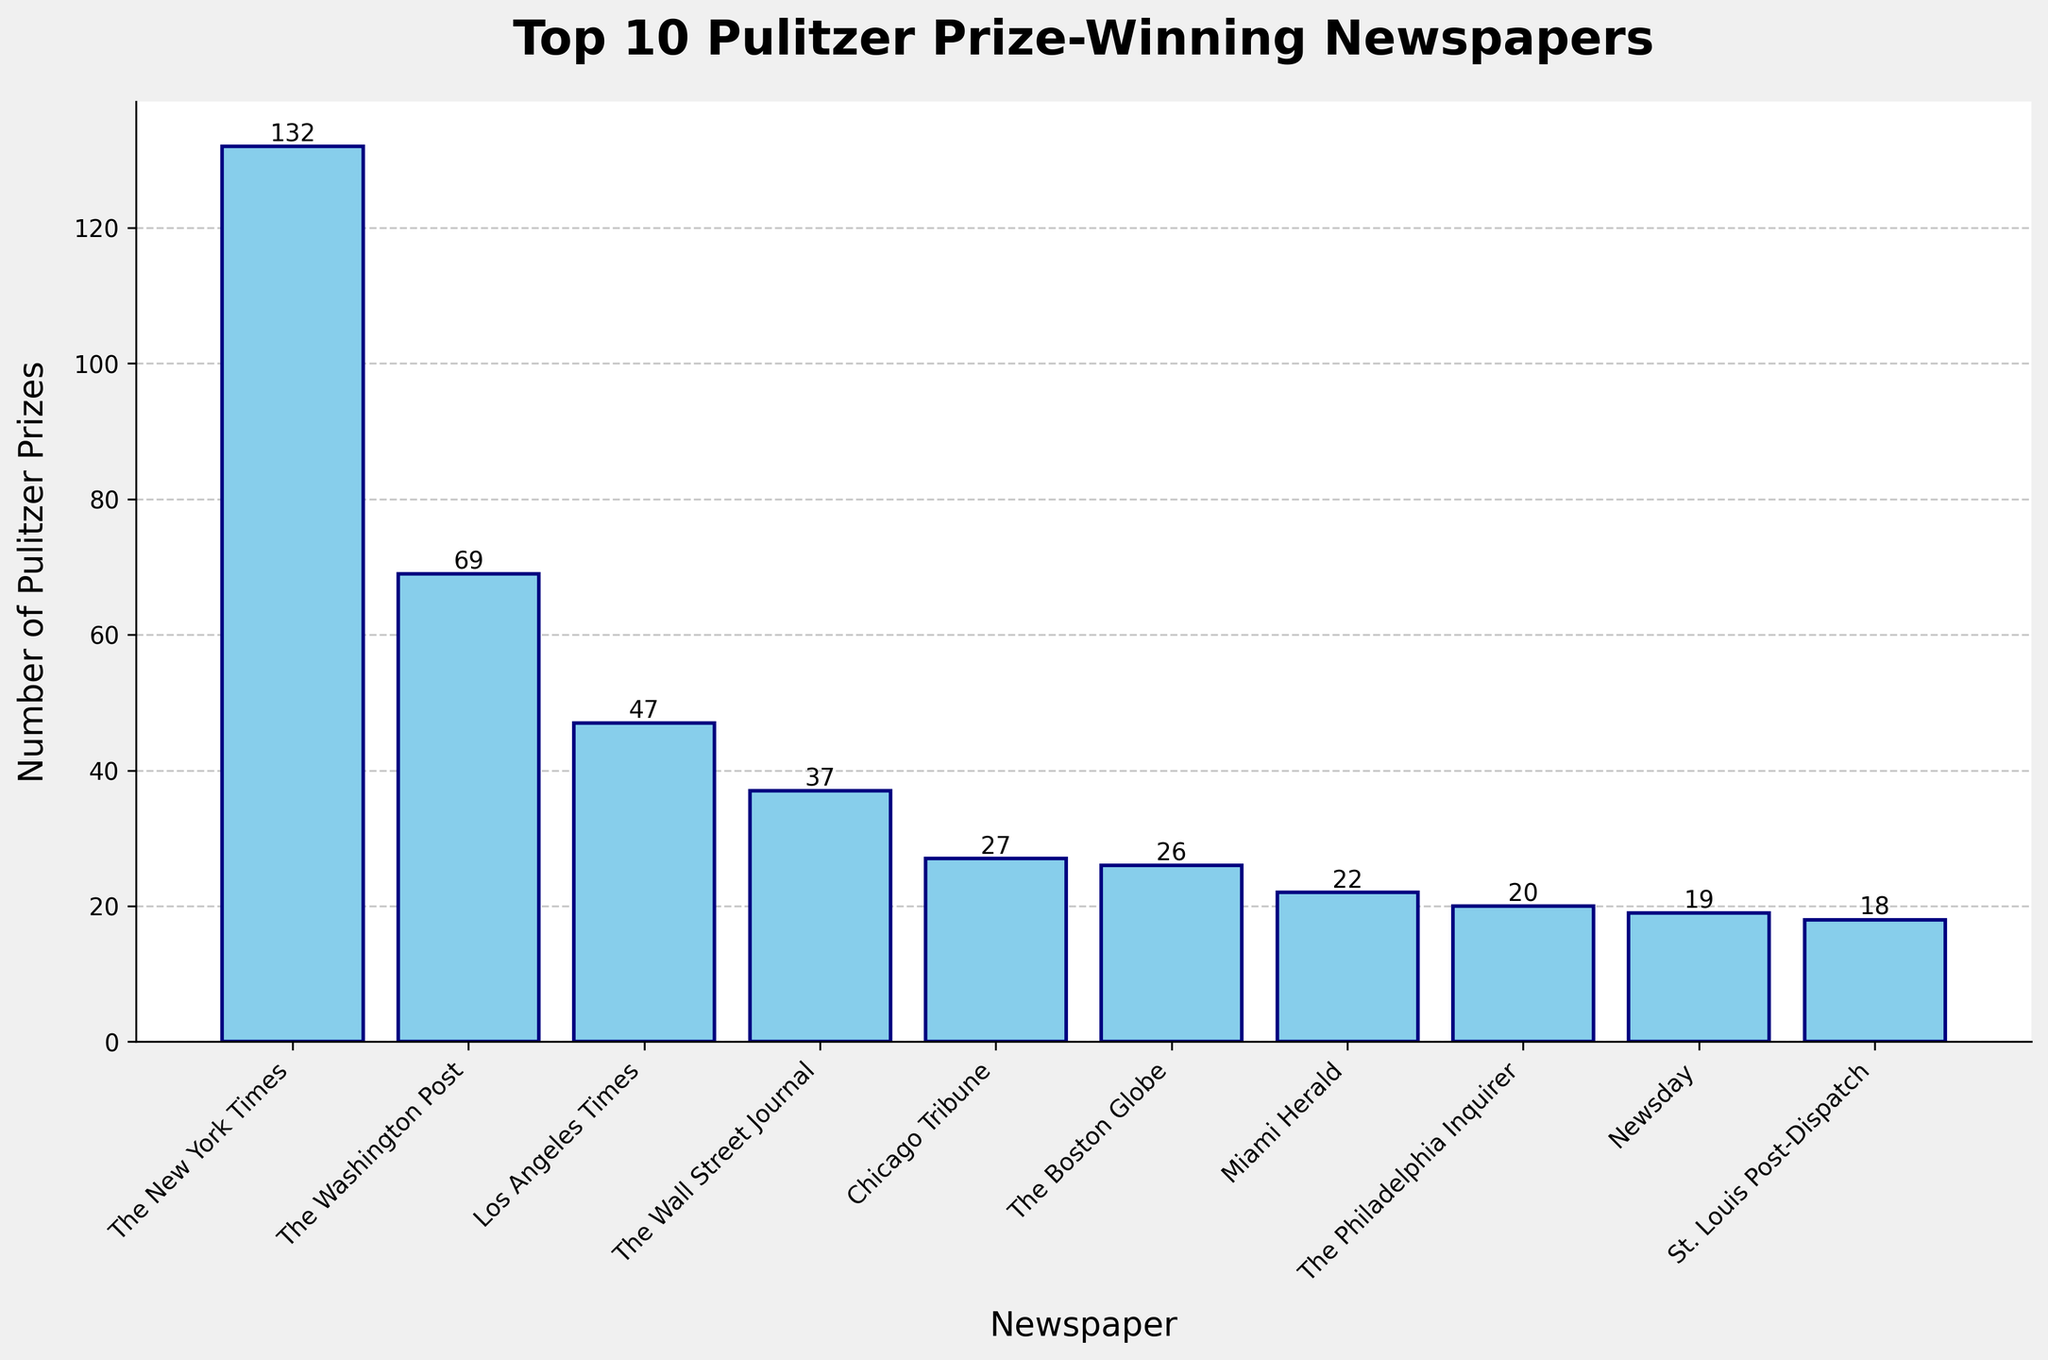Which newspaper has won the most Pulitzer Prizes? The tallest bar represents the newspaper with the most Pulitzer Prizes. The New York Times, with a bar height of 132.
Answer: The New York Times How many Pulitzer Prizes has the Los Angeles Times won? Locate the bar for the Los Angeles Times and look at the value labeled on top of the bar, which is 47.
Answer: 47 What is the difference in Pulitzer Prizes between The New York Times and The Washington Post? The New York Times has 132 prizes and The Washington Post has 69. Subtract 69 from 132 to find the difference. 132 - 69 = 63
Answer: 63 Which newspapers have won between 10 and 25 Pulitzer Prizes? Look at the bars representing values between 10 and 25. The Philadelphia Inquirer (20), Miami Herald (22), Newsday (19), St. Louis Post-Dispatch (18), The Seattle Times (11), and Tampa Bay Times (13).
Answer: The Philadelphia Inquirer, Miami Herald, Newsday, St. Louis Post-Dispatch, The Seattle Times, Tampa Bay Times How many Pulitzer Prizes in total have been won by the top 5 newspapers? The New York Times (132), The Washington Post (69), Los Angeles Times (47), The Wall Street Journal (37), Chicago Tribune (27). Total is 132 + 69 + 47 + 37 + 27 = 312.
Answer: 312 Which newspaper has won fewer Pulitzer Prizes: The Chicago Tribune or The Boston Globe? Compare the heights of the bars for The Chicago Tribune (27) and The Boston Globe (26). The Boston Globe has fewer.
Answer: The Boston Globe Is the number of Pulitzer Prizes won by The Wall Street Journal more than half of that won by The New York Times? Half of 132 (The New York Times' prizes) is 66. Compare it with The Wall Street Journal's 37. 37 is less than 66.
Answer: No What is the total number of Pulitzer Prizes won by newspapers that won 27 or more? Add the Pulitzer Prizes for The New York Times (132), The Washington Post (69), Los Angeles Times (47), The Wall Street Journal (37), and Chicago Tribune (27). Sum: 132 + 69 + 47 + 37 + 27 = 312.
Answer: 312 Which two newspapers have the closest number of Pulitzer Prizes? Compare the heights and values labeled on top of the bars to find the closest numbers. The Chicago Tribune (27) and The Boston Globe (26) are the closest.
Answer: The Chicago Tribune and The Boston Globe 